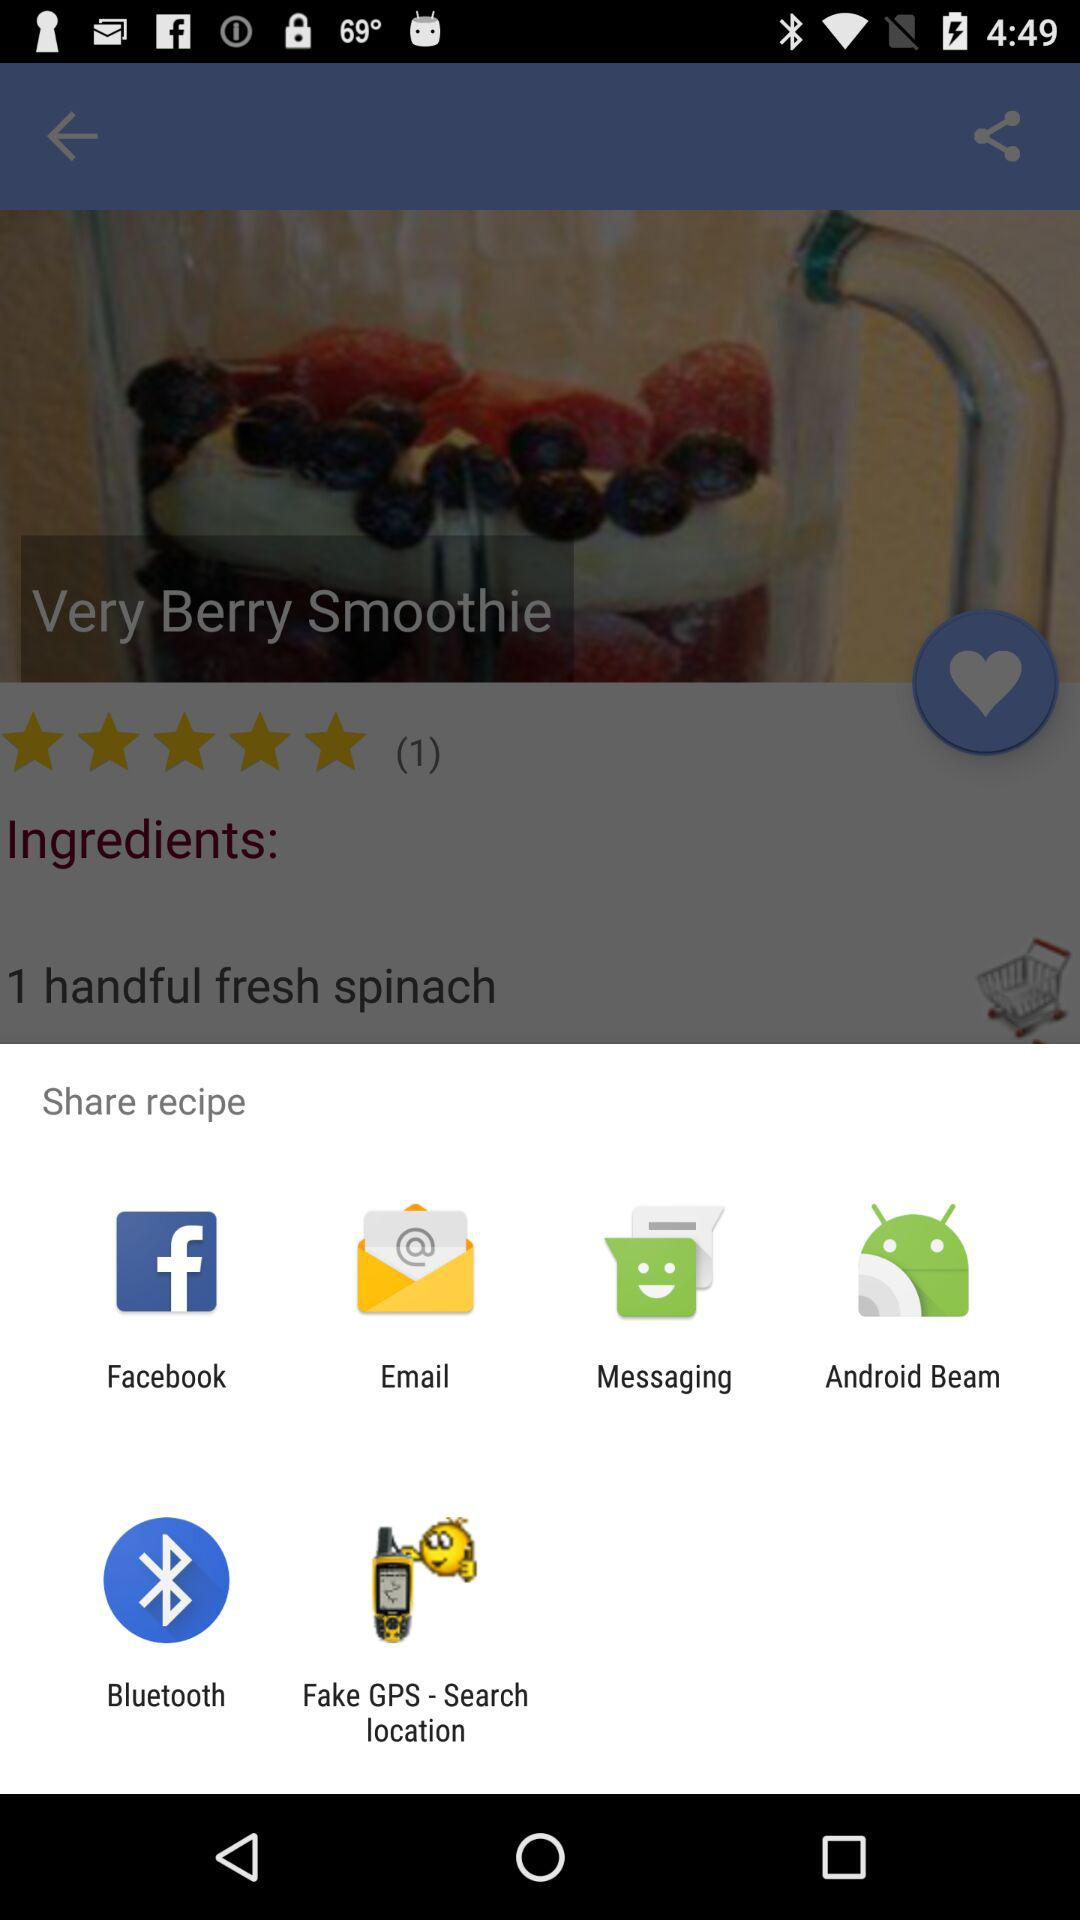What is the name of the recipe? The name of the recipe is "Very Berry Smoothie". 